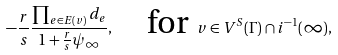Convert formula to latex. <formula><loc_0><loc_0><loc_500><loc_500>- \frac { r } { s } \frac { \prod _ { e \in E ( v ) } d _ { e } } { 1 + \frac { r } { s } \psi _ { \infty } } , \quad \text {for } v \in V ^ { S } ( \Gamma ) \cap i ^ { - 1 } ( \infty ) ,</formula> 